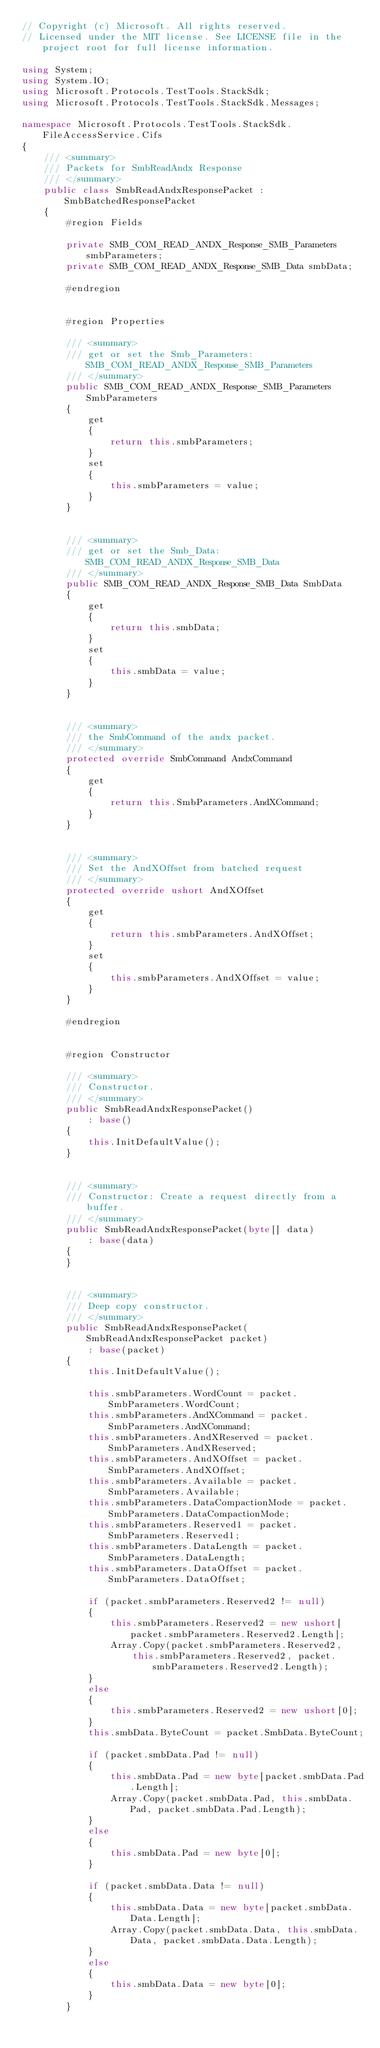Convert code to text. <code><loc_0><loc_0><loc_500><loc_500><_C#_>// Copyright (c) Microsoft. All rights reserved.
// Licensed under the MIT license. See LICENSE file in the project root for full license information.

using System;
using System.IO;
using Microsoft.Protocols.TestTools.StackSdk;
using Microsoft.Protocols.TestTools.StackSdk.Messages;

namespace Microsoft.Protocols.TestTools.StackSdk.FileAccessService.Cifs
{
    /// <summary>
    /// Packets for SmbReadAndx Response
    /// </summary>
    public class SmbReadAndxResponsePacket : SmbBatchedResponsePacket
    {
        #region Fields

        private SMB_COM_READ_ANDX_Response_SMB_Parameters smbParameters;
        private SMB_COM_READ_ANDX_Response_SMB_Data smbData;

        #endregion


        #region Properties

        /// <summary>
        /// get or set the Smb_Parameters:SMB_COM_READ_ANDX_Response_SMB_Parameters
        /// </summary>
        public SMB_COM_READ_ANDX_Response_SMB_Parameters SmbParameters
        {
            get
            {
                return this.smbParameters;
            }
            set
            {
                this.smbParameters = value;
            }
        }


        /// <summary>
        /// get or set the Smb_Data:SMB_COM_READ_ANDX_Response_SMB_Data
        /// </summary>
        public SMB_COM_READ_ANDX_Response_SMB_Data SmbData
        {
            get
            {
                return this.smbData;
            }
            set
            {
                this.smbData = value;
            }
        }


        /// <summary>
        /// the SmbCommand of the andx packet.
        /// </summary>
        protected override SmbCommand AndxCommand
        {
            get
            {
                return this.SmbParameters.AndXCommand;
            }
        }


        /// <summary>
        /// Set the AndXOffset from batched request
        /// </summary>
        protected override ushort AndXOffset
        {
            get
            {
                return this.smbParameters.AndXOffset;
            }
            set
            {
                this.smbParameters.AndXOffset = value;
            }
        }

        #endregion


        #region Constructor

        /// <summary>
        /// Constructor.
        /// </summary>
        public SmbReadAndxResponsePacket()
            : base()
        {
            this.InitDefaultValue();
        }


        /// <summary>
        /// Constructor: Create a request directly from a buffer.
        /// </summary>
        public SmbReadAndxResponsePacket(byte[] data)
            : base(data)
        {
        }


        /// <summary>
        /// Deep copy constructor.
        /// </summary>
        public SmbReadAndxResponsePacket(SmbReadAndxResponsePacket packet)
            : base(packet)
        {
            this.InitDefaultValue();

            this.smbParameters.WordCount = packet.SmbParameters.WordCount;
            this.smbParameters.AndXCommand = packet.SmbParameters.AndXCommand;
            this.smbParameters.AndXReserved = packet.SmbParameters.AndXReserved;
            this.smbParameters.AndXOffset = packet.SmbParameters.AndXOffset;
            this.smbParameters.Available = packet.SmbParameters.Available;
            this.smbParameters.DataCompactionMode = packet.SmbParameters.DataCompactionMode;
            this.smbParameters.Reserved1 = packet.SmbParameters.Reserved1;
            this.smbParameters.DataLength = packet.SmbParameters.DataLength;
            this.smbParameters.DataOffset = packet.SmbParameters.DataOffset;

            if (packet.smbParameters.Reserved2 != null)
            {
                this.smbParameters.Reserved2 = new ushort[packet.smbParameters.Reserved2.Length];
                Array.Copy(packet.smbParameters.Reserved2,
                    this.smbParameters.Reserved2, packet.smbParameters.Reserved2.Length);
            }
            else
            {
                this.smbParameters.Reserved2 = new ushort[0];
            }
            this.smbData.ByteCount = packet.SmbData.ByteCount;

            if (packet.smbData.Pad != null)
            {
                this.smbData.Pad = new byte[packet.smbData.Pad.Length];
                Array.Copy(packet.smbData.Pad, this.smbData.Pad, packet.smbData.Pad.Length);
            }
            else
            {
                this.smbData.Pad = new byte[0];
            }

            if (packet.smbData.Data != null)
            {
                this.smbData.Data = new byte[packet.smbData.Data.Length];
                Array.Copy(packet.smbData.Data, this.smbData.Data, packet.smbData.Data.Length);
            }
            else
            {
                this.smbData.Data = new byte[0];
            }
        }
</code> 